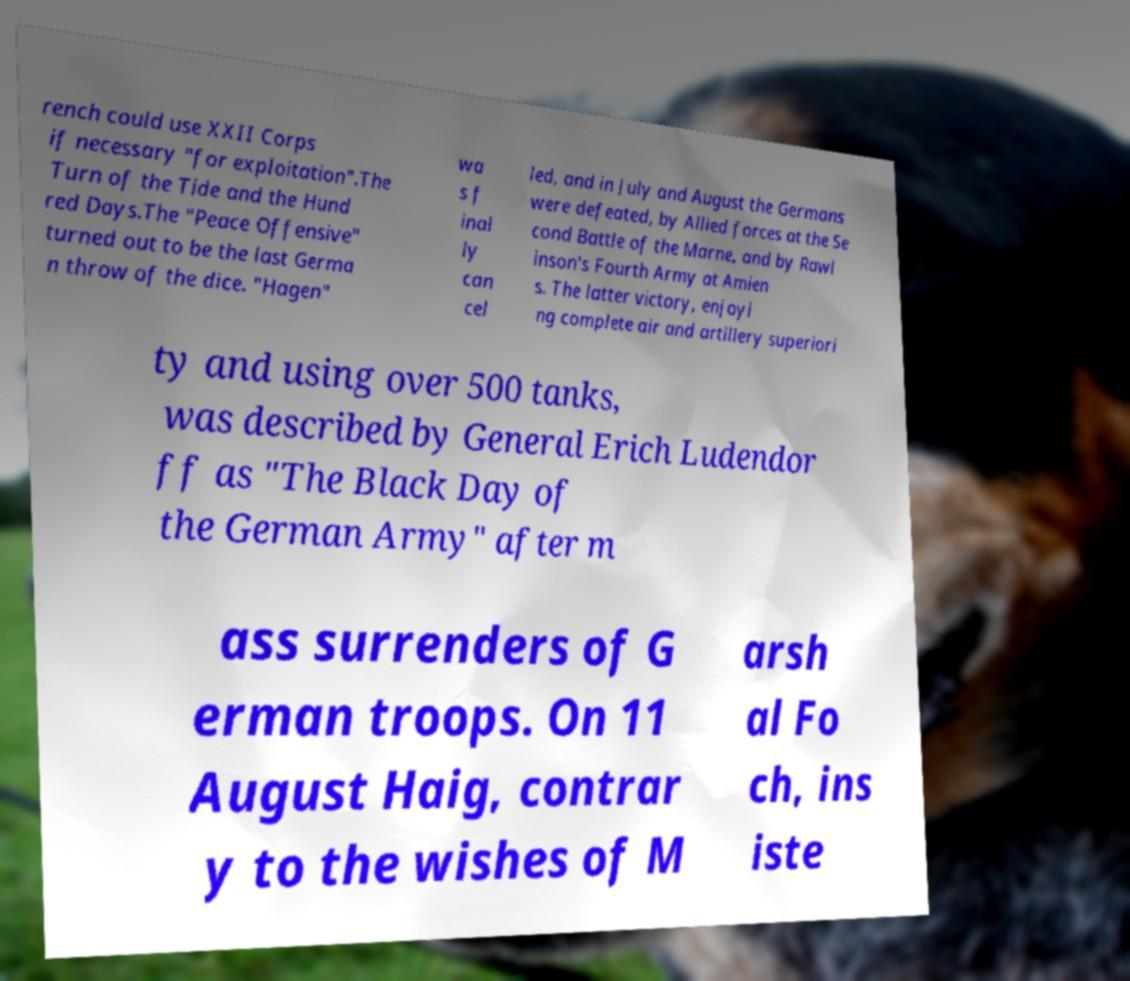Could you assist in decoding the text presented in this image and type it out clearly? rench could use XXII Corps if necessary "for exploitation".The Turn of the Tide and the Hund red Days.The "Peace Offensive" turned out to be the last Germa n throw of the dice. "Hagen" wa s f inal ly can cel led, and in July and August the Germans were defeated, by Allied forces at the Se cond Battle of the Marne, and by Rawl inson's Fourth Army at Amien s. The latter victory, enjoyi ng complete air and artillery superiori ty and using over 500 tanks, was described by General Erich Ludendor ff as "The Black Day of the German Army" after m ass surrenders of G erman troops. On 11 August Haig, contrar y to the wishes of M arsh al Fo ch, ins iste 